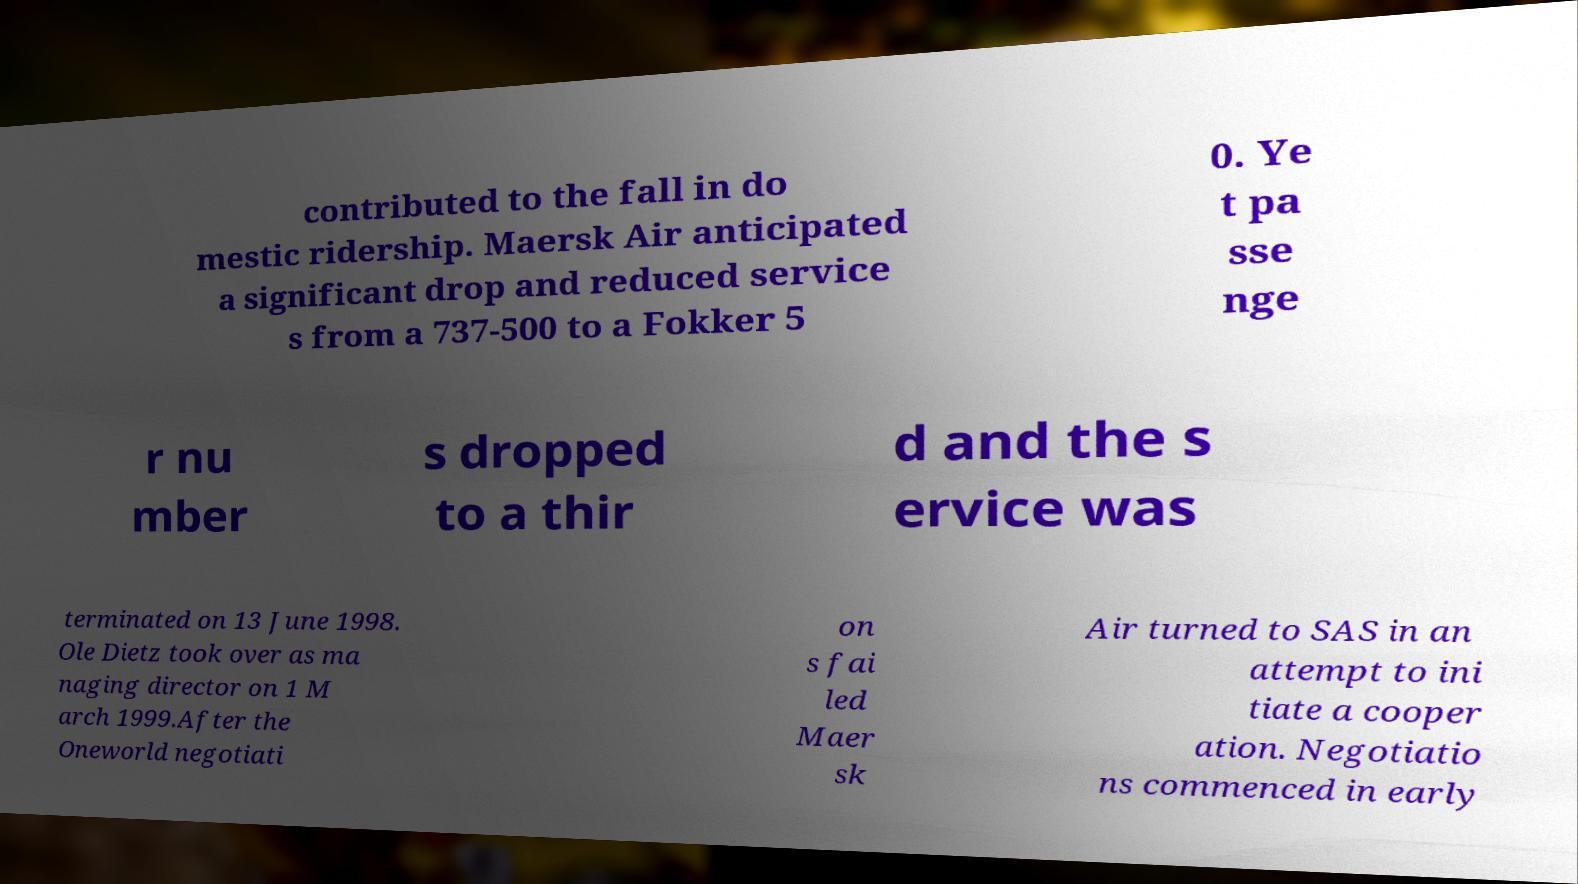What messages or text are displayed in this image? I need them in a readable, typed format. contributed to the fall in do mestic ridership. Maersk Air anticipated a significant drop and reduced service s from a 737-500 to a Fokker 5 0. Ye t pa sse nge r nu mber s dropped to a thir d and the s ervice was terminated on 13 June 1998. Ole Dietz took over as ma naging director on 1 M arch 1999.After the Oneworld negotiati on s fai led Maer sk Air turned to SAS in an attempt to ini tiate a cooper ation. Negotiatio ns commenced in early 